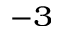Convert formula to latex. <formula><loc_0><loc_0><loc_500><loc_500>^ { - 3 }</formula> 